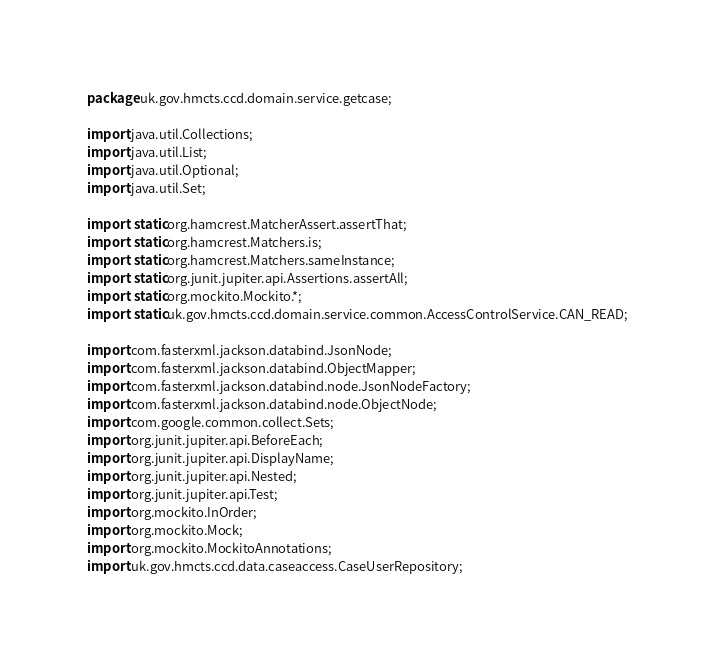Convert code to text. <code><loc_0><loc_0><loc_500><loc_500><_Java_>package uk.gov.hmcts.ccd.domain.service.getcase;

import java.util.Collections;
import java.util.List;
import java.util.Optional;
import java.util.Set;

import static org.hamcrest.MatcherAssert.assertThat;
import static org.hamcrest.Matchers.is;
import static org.hamcrest.Matchers.sameInstance;
import static org.junit.jupiter.api.Assertions.assertAll;
import static org.mockito.Mockito.*;
import static uk.gov.hmcts.ccd.domain.service.common.AccessControlService.CAN_READ;

import com.fasterxml.jackson.databind.JsonNode;
import com.fasterxml.jackson.databind.ObjectMapper;
import com.fasterxml.jackson.databind.node.JsonNodeFactory;
import com.fasterxml.jackson.databind.node.ObjectNode;
import com.google.common.collect.Sets;
import org.junit.jupiter.api.BeforeEach;
import org.junit.jupiter.api.DisplayName;
import org.junit.jupiter.api.Nested;
import org.junit.jupiter.api.Test;
import org.mockito.InOrder;
import org.mockito.Mock;
import org.mockito.MockitoAnnotations;
import uk.gov.hmcts.ccd.data.caseaccess.CaseUserRepository;</code> 